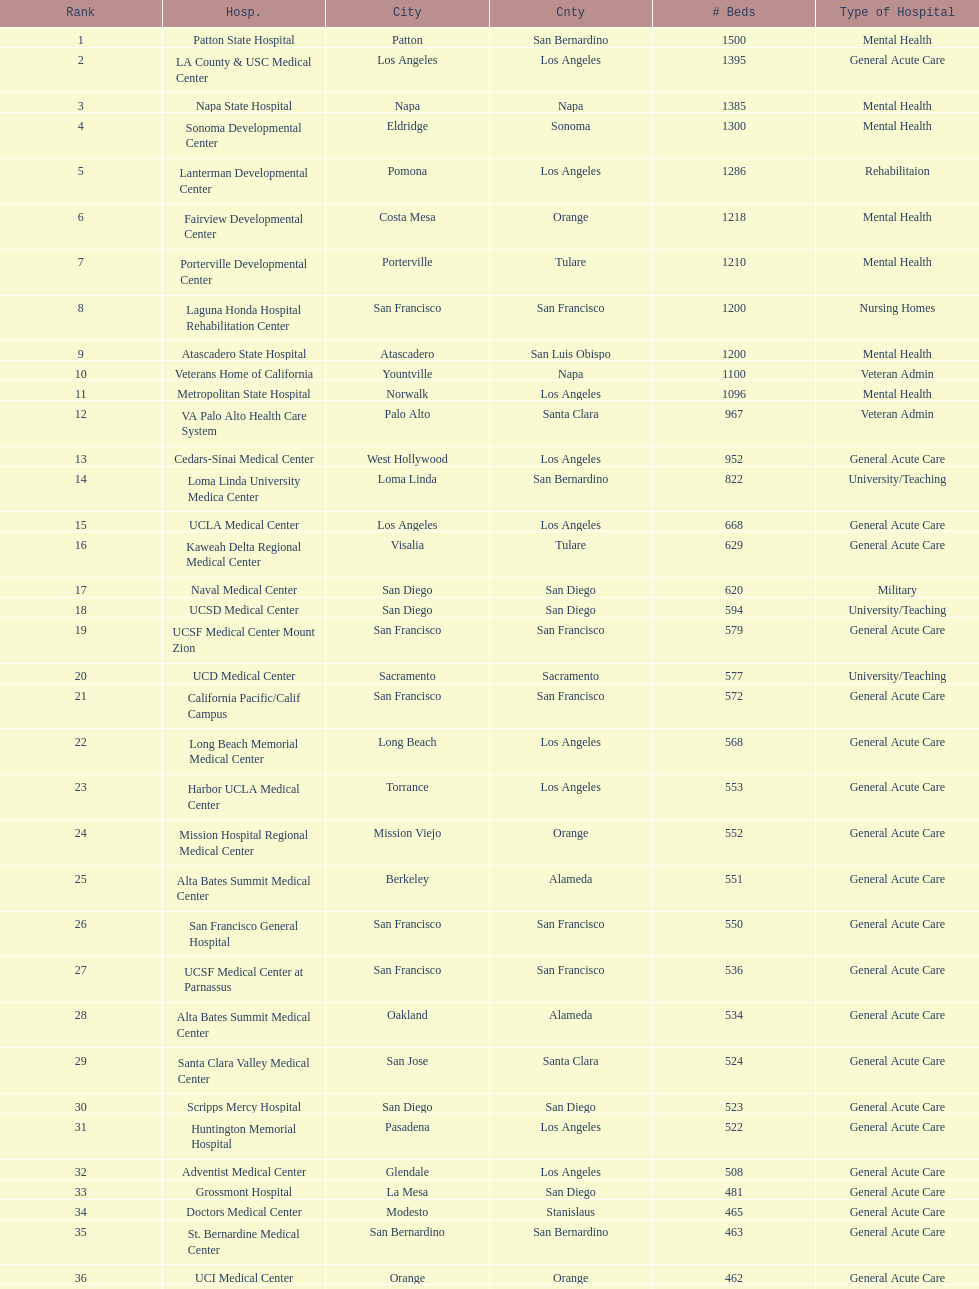What hospital in los angeles county providing hospital beds specifically for rehabilitation is ranked at least among the top 10 hospitals? Lanterman Developmental Center. 